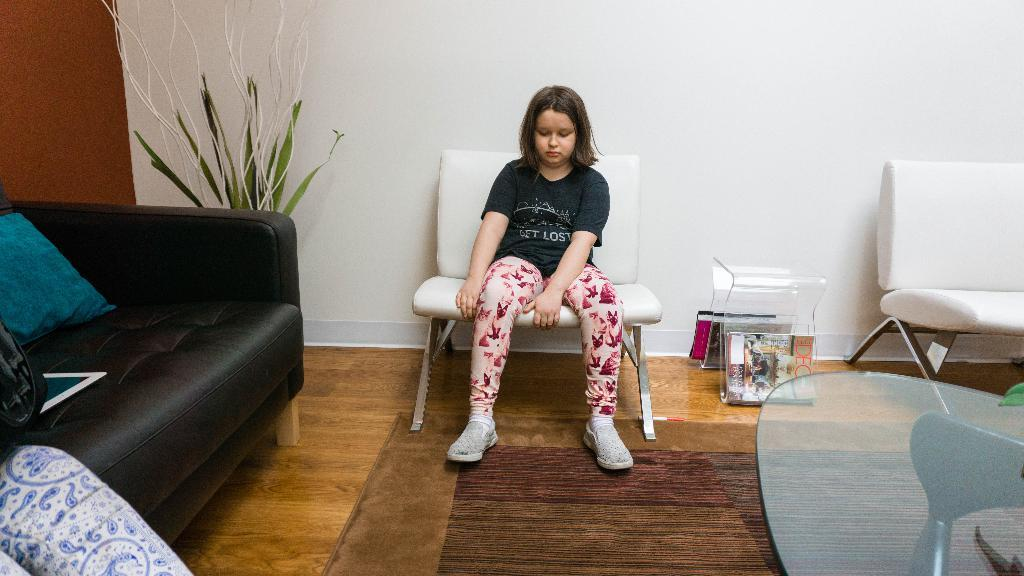What is the girl in the image doing? The girl is sitting on a chair in the image. What type of furniture is visible in the image besides the chair? There are sofa pillows, stools, and a table visible in the image. What can be seen outside the room in the image? There is a tree visible in the image. What is the background of the image? There is a wall visible in the background of the image. What type of cork is used to hold the curtain on the wall in the image? There is no cork or curtain present in the image. What type of crib can be seen in the image? There is no crib present in the image. 